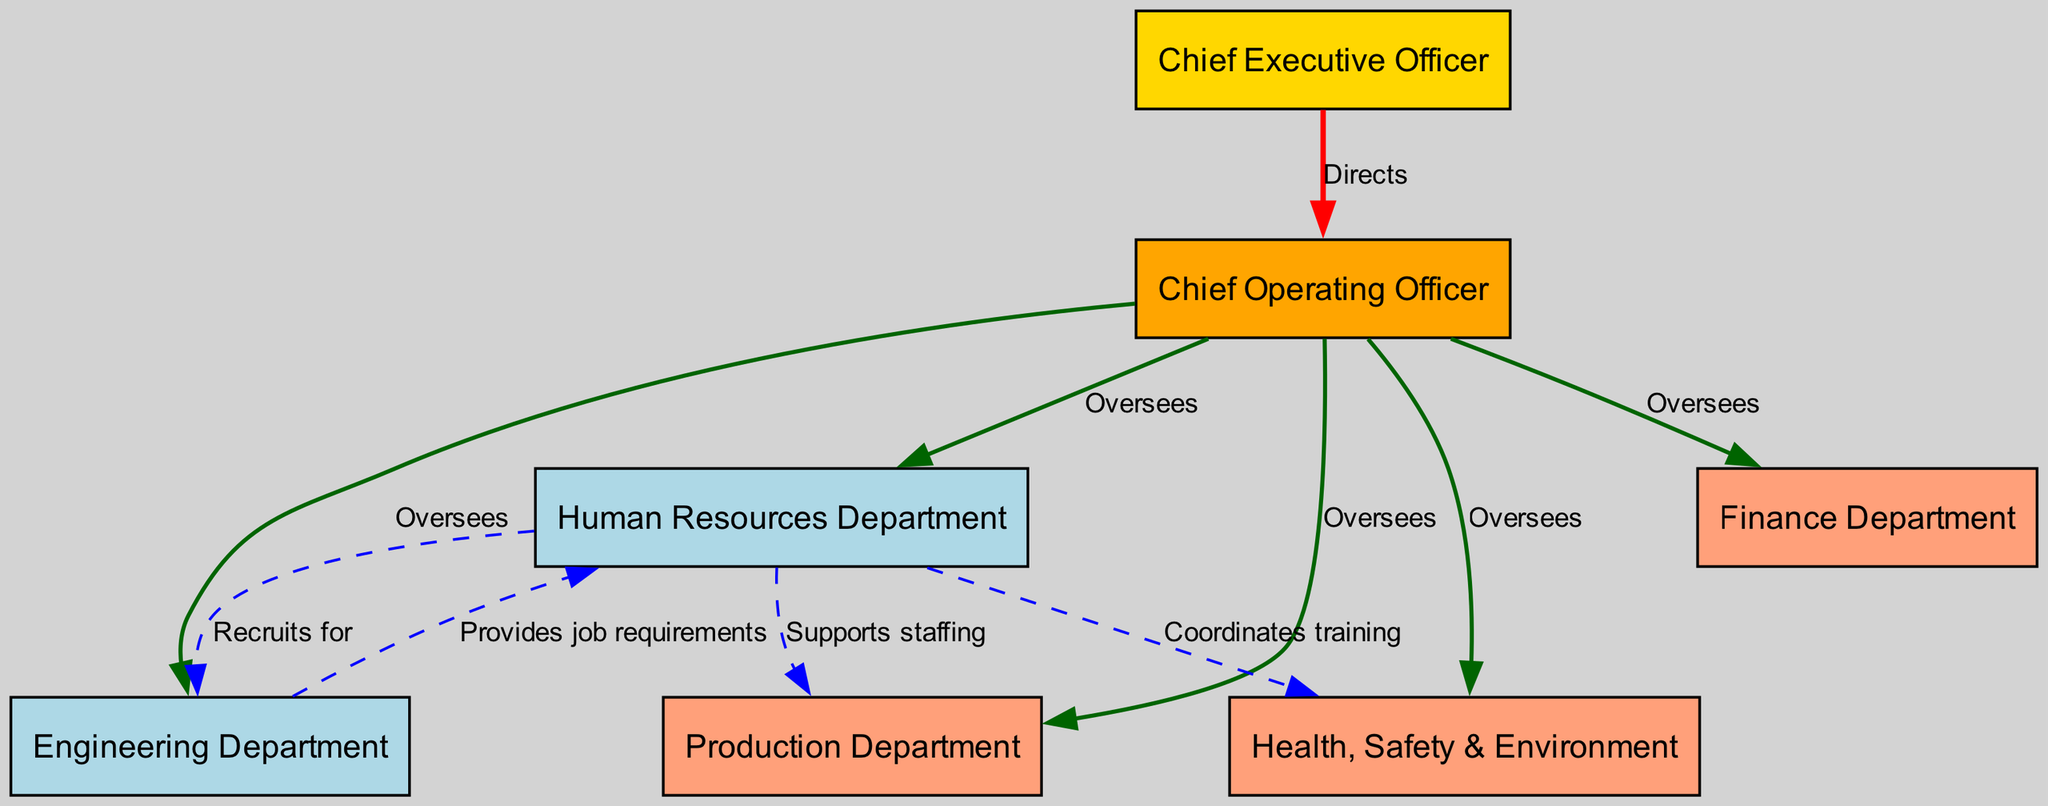What is the title of the highest role in the chart? The highest role in the chart is represented by the "CEO" node, which is labeled as "Chief Executive Officer." This is determined by identifying the node at the top of the hierarchy in the organizational chart.
Answer: Chief Executive Officer How many departments does the COO oversee? The COO oversees five departments, which are HR, Engineering, Production, Health, Safety & Environment, and Finance. This can be confirmed by counting the outgoing edges from the COO node to other departmental nodes.
Answer: Five What function does HR provide to Engineering? HR provides job requirements to the Engineering Department, indicated by the directed edge connecting HR to ENG with the label "Provides job requirements." This means that HR plays a role in identifying what the engineering team needs in terms of staffing and roles.
Answer: Provides job requirements What is the relationship between HR and Production? The relationship between HR and Production is labeled as "Supports staffing," indicating that HR is involved in ensuring that the Production Department is adequately staffed. This is visible as a directed edge from HR to PRODUCTION in the diagram.
Answer: Supports staffing Which department is in direct reporting relation to the CEO? The department in direct reporting relation to the CEO is the COO, as there is a direct edge labeled "Directs" from the CEO to COO, indicating that the CEO has oversight over the COO's role.
Answer: Chief Operating Officer Which department provides training coordination to HR? The Health, Safety & Environment department (HSE) coordinates training with HR, as indicated by the directed edge from HSE to HR labeled "Coordinates training." This shows that HSE collaborates with HR in staff training efforts.
Answer: Health, Safety & Environment How many departments have a direct connection to HR? There are three departments that have a direct connection to HR: Engineering, Production, and Health, Safety & Environment. Each of these departments is connected to HR with a directed edge indicating either recruitment or training coordination role.
Answer: Three What color represents the Engineering Department in the diagram? The Engineering Department is represented by the color light blue. This is determined by the node's color attribute specified in the diagram setup for departments like HR and Engineering.
Answer: Light blue What is the nature of the relationship between COO and the Finance Department? The nature of the relationship is labeled as "Oversees," meaning that the COO supervises the Finance Department. This relationship is indicated by the directed edge from COO to FIN in the diagram.
Answer: Oversees 